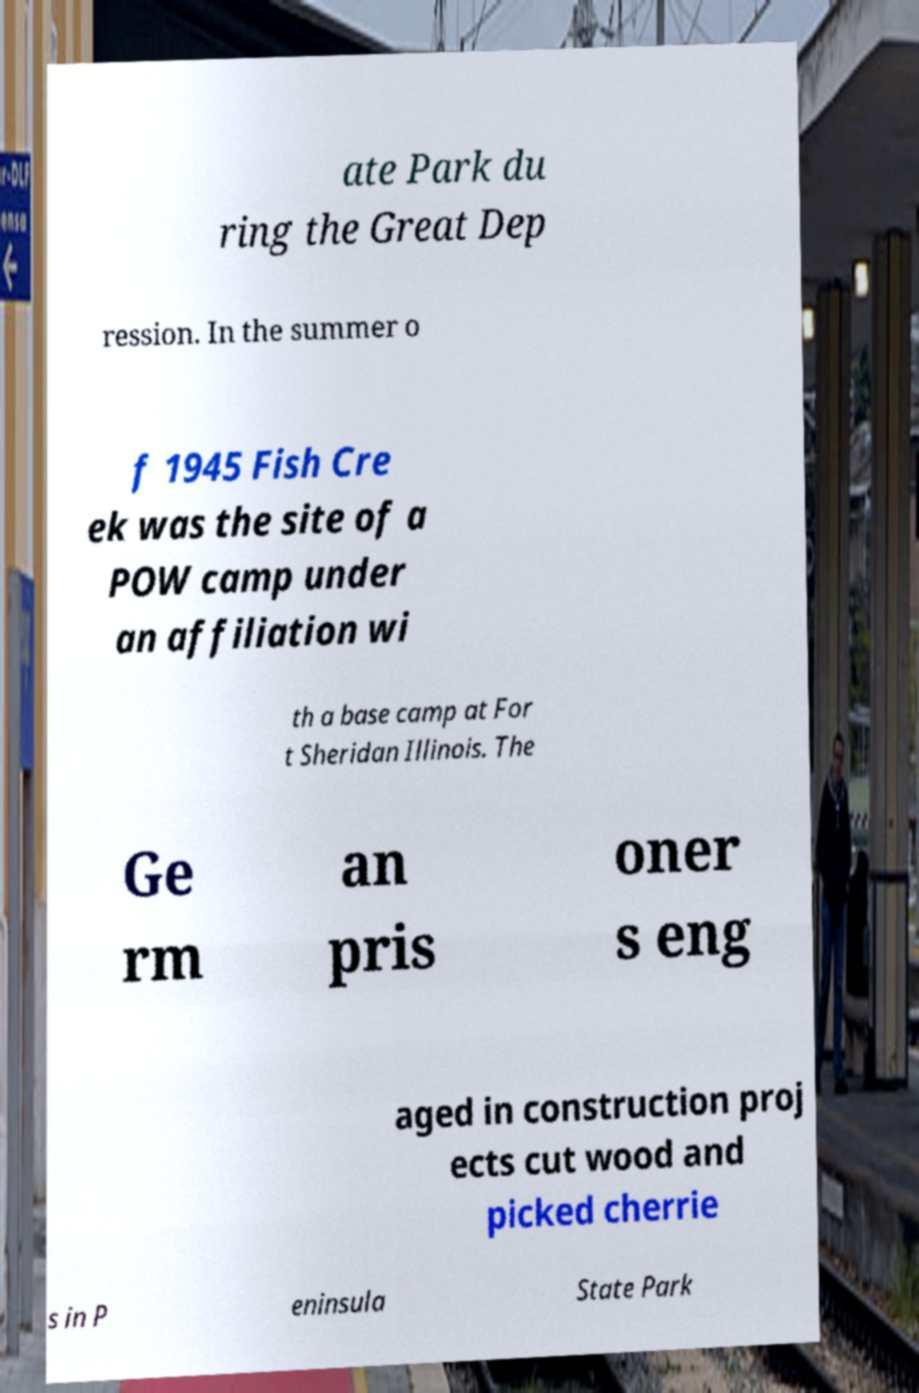There's text embedded in this image that I need extracted. Can you transcribe it verbatim? ate Park du ring the Great Dep ression. In the summer o f 1945 Fish Cre ek was the site of a POW camp under an affiliation wi th a base camp at For t Sheridan Illinois. The Ge rm an pris oner s eng aged in construction proj ects cut wood and picked cherrie s in P eninsula State Park 